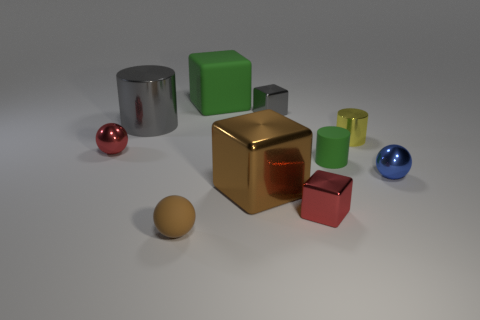The small rubber cylinder has what color? The small cylinder located in the center-right of the image has a gentle, matte green hue. 